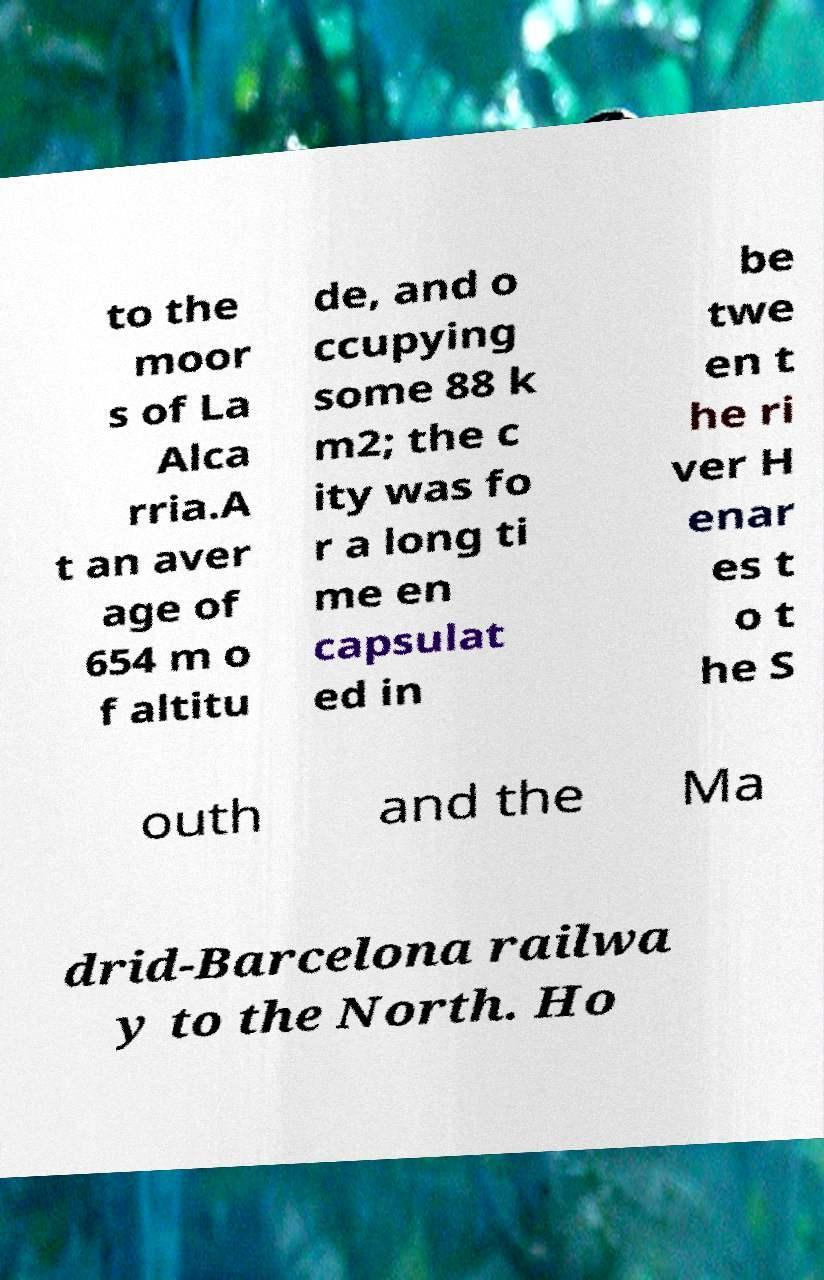Could you extract and type out the text from this image? to the moor s of La Alca rria.A t an aver age of 654 m o f altitu de, and o ccupying some 88 k m2; the c ity was fo r a long ti me en capsulat ed in be twe en t he ri ver H enar es t o t he S outh and the Ma drid-Barcelona railwa y to the North. Ho 